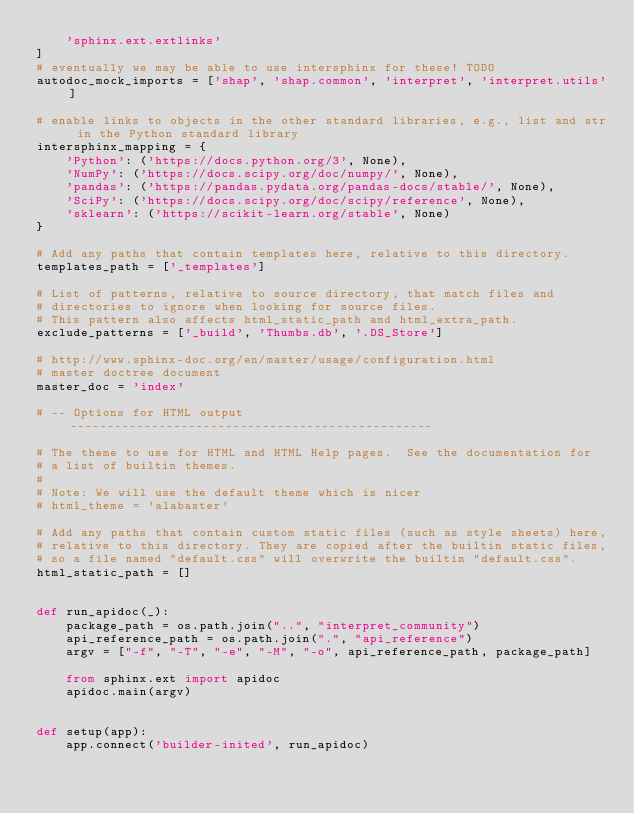<code> <loc_0><loc_0><loc_500><loc_500><_Python_>    'sphinx.ext.extlinks'
]
# eventually we may be able to use intersphinx for these! TODO
autodoc_mock_imports = ['shap', 'shap.common', 'interpret', 'interpret.utils']

# enable links to objects in the other standard libraries, e.g., list and str in the Python standard library
intersphinx_mapping = {
    'Python': ('https://docs.python.org/3', None),
    'NumPy': ('https://docs.scipy.org/doc/numpy/', None),
    'pandas': ('https://pandas.pydata.org/pandas-docs/stable/', None),
    'SciPy': ('https://docs.scipy.org/doc/scipy/reference', None),
    'sklearn': ('https://scikit-learn.org/stable', None)
}

# Add any paths that contain templates here, relative to this directory.
templates_path = ['_templates']

# List of patterns, relative to source directory, that match files and
# directories to ignore when looking for source files.
# This pattern also affects html_static_path and html_extra_path.
exclude_patterns = ['_build', 'Thumbs.db', '.DS_Store']

# http://www.sphinx-doc.org/en/master/usage/configuration.html
# master doctree document
master_doc = 'index'

# -- Options for HTML output -------------------------------------------------

# The theme to use for HTML and HTML Help pages.  See the documentation for
# a list of builtin themes.
#
# Note: We will use the default theme which is nicer
# html_theme = 'alabaster'

# Add any paths that contain custom static files (such as style sheets) here,
# relative to this directory. They are copied after the builtin static files,
# so a file named "default.css" will overwrite the builtin "default.css".
html_static_path = []


def run_apidoc(_):
    package_path = os.path.join("..", "interpret_community")
    api_reference_path = os.path.join(".", "api_reference")
    argv = ["-f", "-T", "-e", "-M", "-o", api_reference_path, package_path]

    from sphinx.ext import apidoc
    apidoc.main(argv)


def setup(app):
    app.connect('builder-inited', run_apidoc)
</code> 